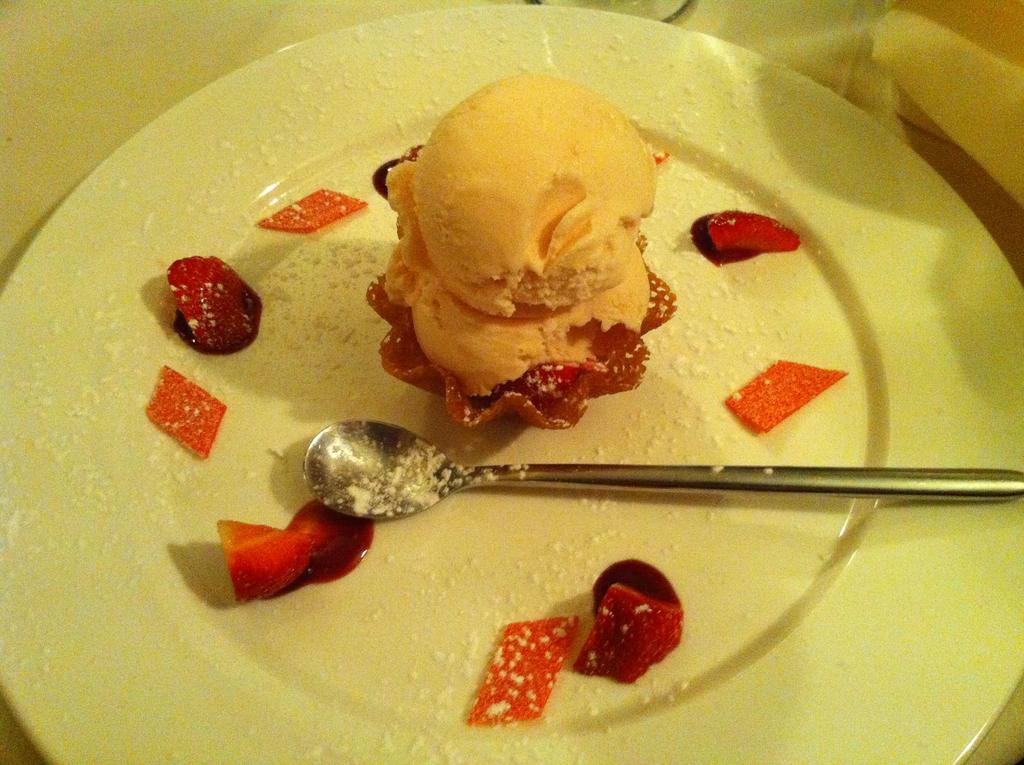What is on the plate in the image? There is a food item on a plate in the image. What utensil is on the plate with the food item? There is a spoon on the plate in the image. Where is the plate located in the image? The plate is on a table in the image. What else can be seen beside the plate on the table? There are objects beside the plate in the image. How many chickens are visible behind the plate in the image? There are no chickens visible in the image; it only shows a plate with a food item and a spoon on a table, along with some objects beside the plate. 